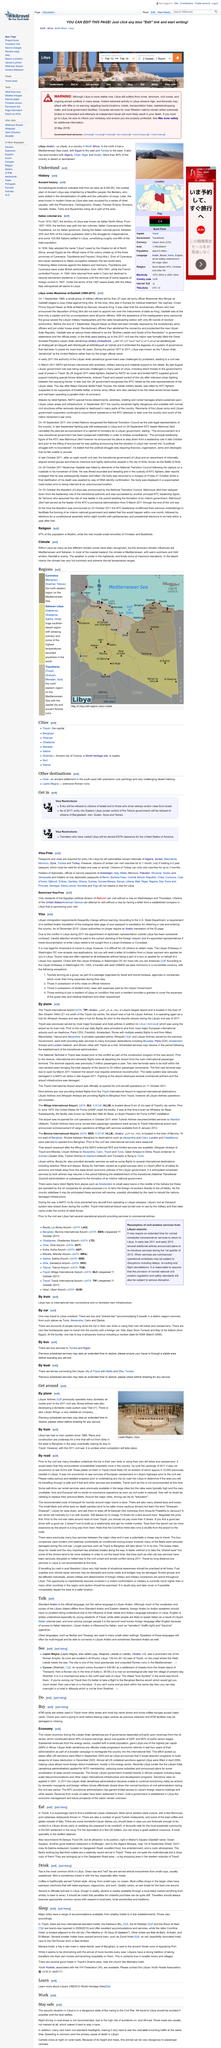Draw attention to some important aspects in this diagram. The official language of Libya is Libyan Arabic, as declared. Citizens of the United States/American Samoa can enter Libya without a visa if they possess a letter from a established company in Libya that sponsors their visit, as per the Libyan visa policy. The fish restaurant in the souq is a popular cafe among the local expatriate community. Libyan Arabic has been influenced by Italian, a European language. Libya allows visa-free entry to citizens of Algeria, Jordan, Mauritania, Morocco, Syria, Tunisia, and Turkey. 